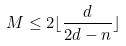<formula> <loc_0><loc_0><loc_500><loc_500>M \leq 2 \lfloor \frac { d } { 2 d - n } \rfloor</formula> 